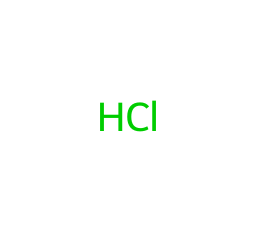What is the chemical symbol for chlorine? The SMILES representation shows "Cl," which is the standard chemical symbol used to denote the element chlorine in chemistry.
Answer: Cl How many valence electrons does chlorine have? Chlorine belongs to group 17 of the periodic table, which indicates that it has seven valence electrons, as all elements in this group have a common valence electron configuration.
Answer: 7 Is chlorine a gas at room temperature? Chlorine is known to be a diatomic gas (Cl2) in its gaseous form at room temperature, and given that the SMILES representation only shows the atomic symbol, we refer to its common state under standard conditions.
Answer: Yes What kind of bond does chlorine typically form in compounds? Chlorine commonly forms covalent bonds due to its ability to share electrons with other elements which occurs when it combines with them, especially nonmetals.
Answer: Covalent What is a major health hazard associated with chlorine exposure? Chlorine can cause respiratory issues and skin irritation upon exposure, and this fact is well-documented in safety data sheets and medical literature about chlorine's hazardous nature.
Answer: Respiratory issues In what disinfecting form can chlorine be commonly found? Chlorine is frequently used in the form of sodium hypochlorite (bleach) for disinfection purposes, which aligns with common public health practices for sanitation.
Answer: Sodium hypochlorite What precaution should be taken when handling chlorine? It is crucial to handle chlorine in well-ventilated areas to prevent inhalation of its toxic fumes, which is a safety standard in chemical handling protocols.
Answer: Ventilation 